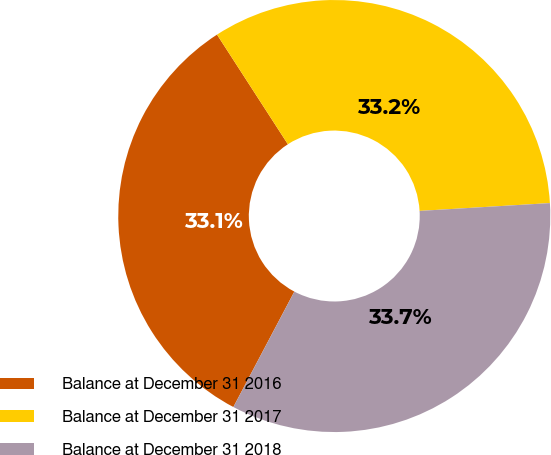<chart> <loc_0><loc_0><loc_500><loc_500><pie_chart><fcel>Balance at December 31 2016<fcel>Balance at December 31 2017<fcel>Balance at December 31 2018<nl><fcel>33.13%<fcel>33.18%<fcel>33.69%<nl></chart> 